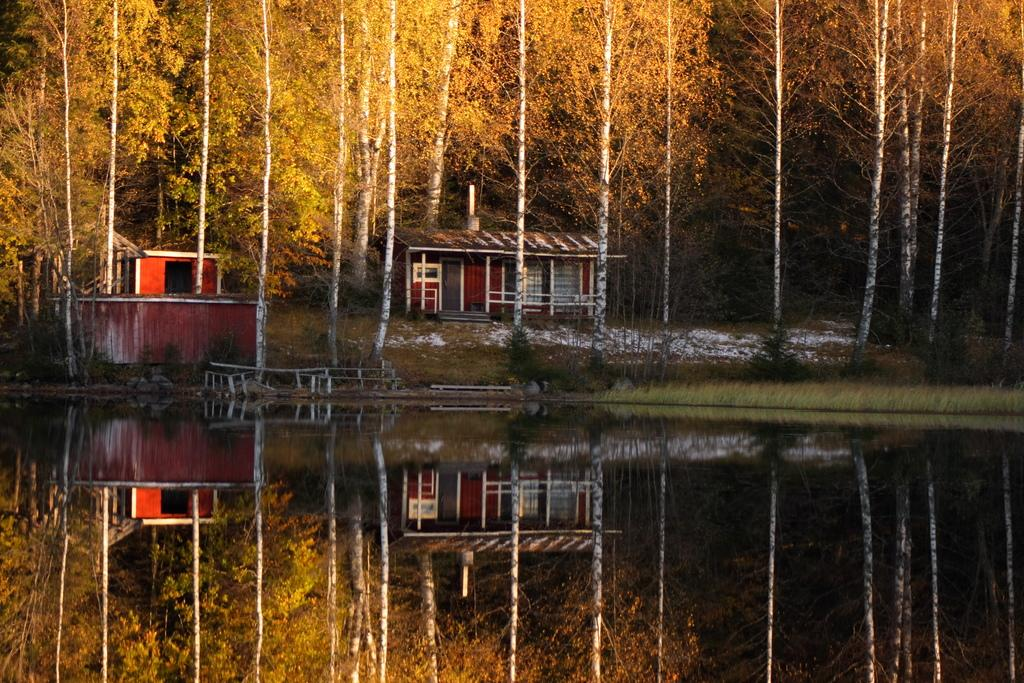What is visible in the image? Water, trees, and houses are visible in the image. Can you describe the natural elements in the image? There are trees in the image. Are there any man-made structures visible? Yes, there are houses in the image. What type of hydrant can be seen in the image? There is no hydrant present in the image. What emotion is being conveyed by the trees in the image? The trees in the image do not convey emotions; they are inanimate objects. 